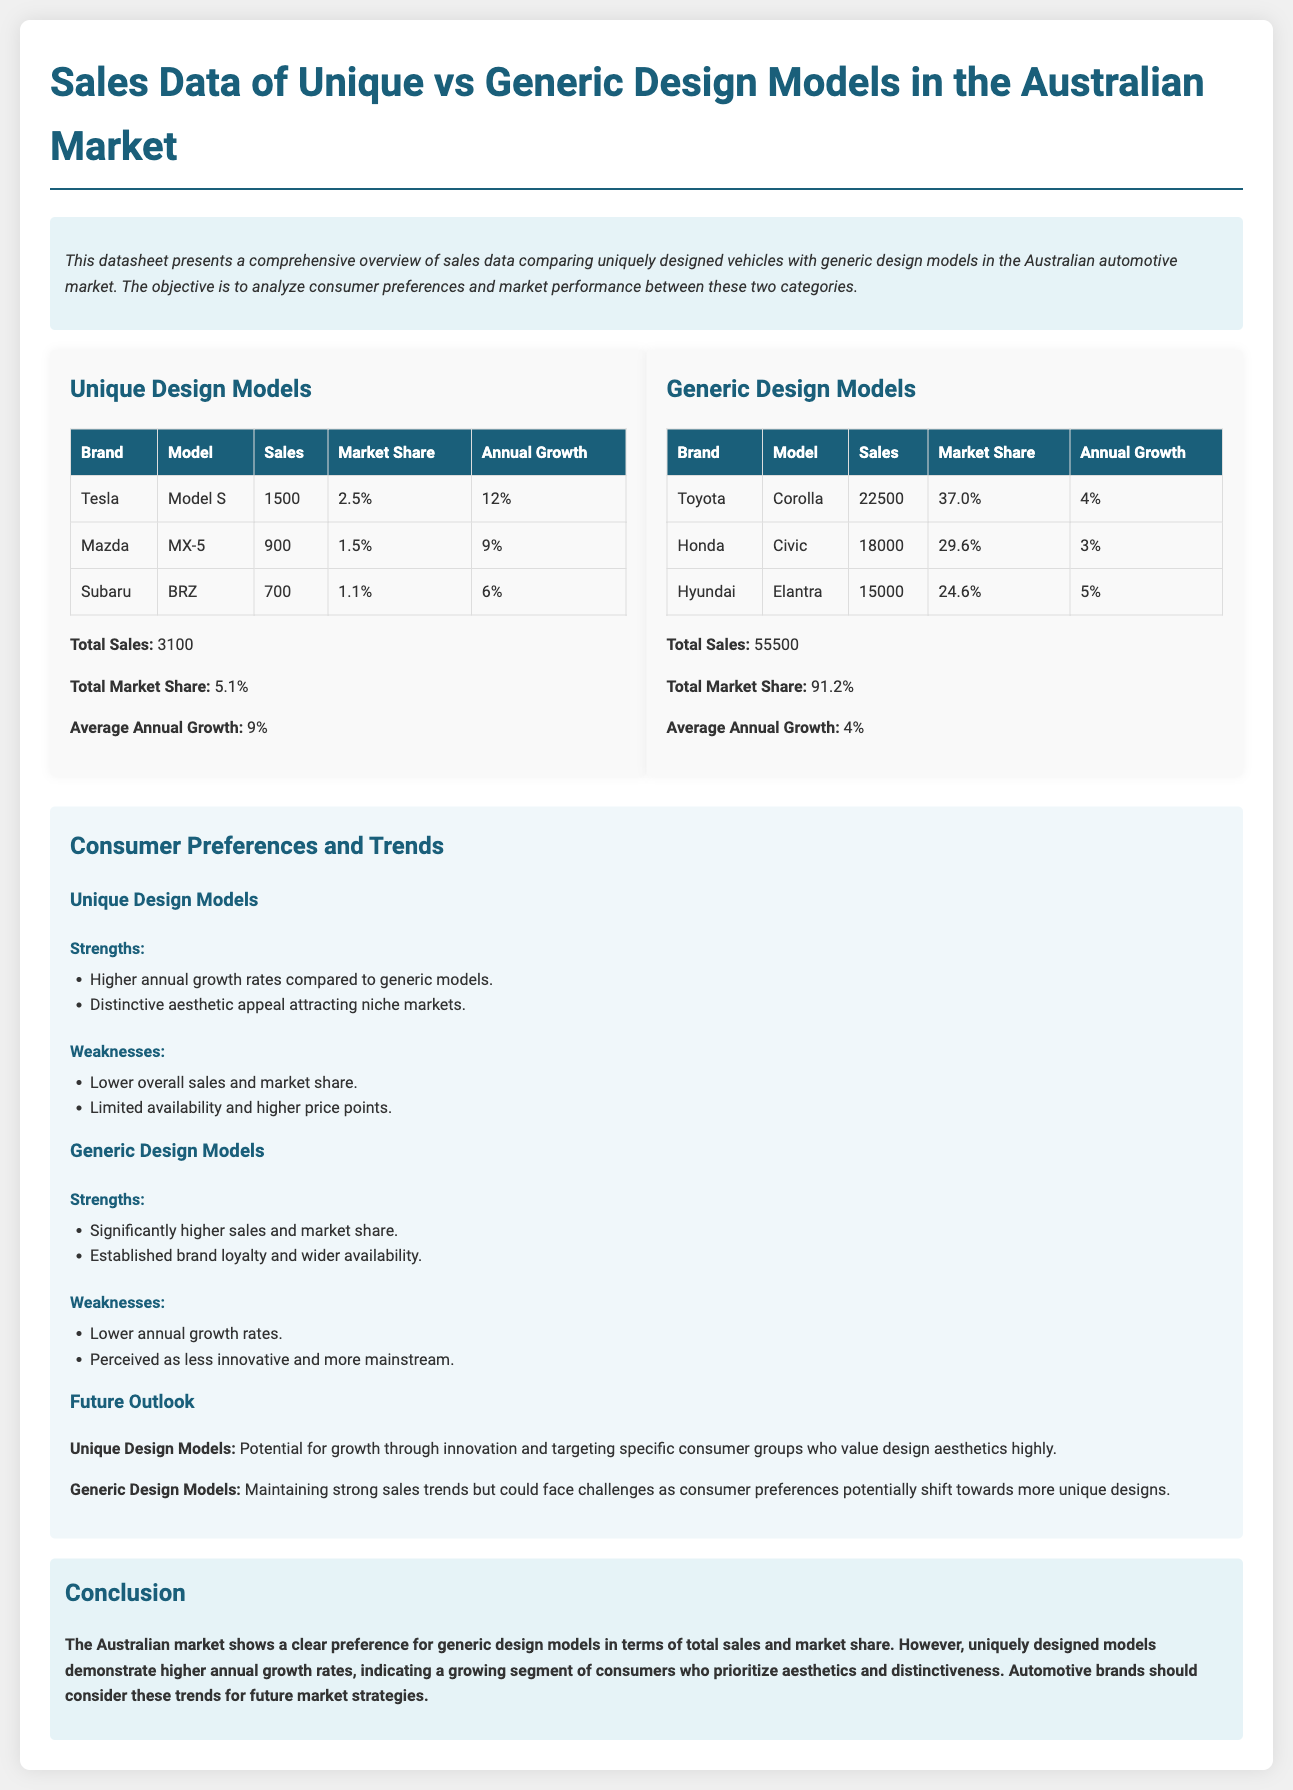What is the total sales of Unique Design Models? The total sales of Unique Design Models are listed in the document and are calculated by summing individual sales figures.
Answer: 3100 What is the market share percentage of Generic Design Models? The document states the market share percentage of Generic Design Models calculated from the total sales relative to the total market.
Answer: 91.2% Which brand has the highest sales in Unique Design Models? The document lists the sales figures for each brand under Unique Design Models, identifying the brand with the highest sales.
Answer: Tesla What is the average annual growth for Unique Design Models? The document provides the average annual growth figure specifically for Unique Design Models in the summary.
Answer: 9% What is the weakness of Generic Design Models mentioned in the analysis? The analysis section lists weaknesses associated with Generic Design Models, allowing for identification of the stated weaknesses.
Answer: Lower annual growth rates What was the annual growth percentage for Toyota Corolla? The document specifies the annual growth percentage for each model under Generic Design Models, particularly highlighting Toyota Corolla’s growth rate.
Answer: 4% What is the total market share of Unique Design Models? The total market share for Unique Design Models is explicitly mentioned as part of the sales data summary in the document.
Answer: 5.1% What does the conclusion suggest about the future of Unique Design Models? The conclusion discusses market trends and indicates the unique models' potential for growth, reflecting on consumer preferences.
Answer: Potential for growth through innovation What are the strengths of Subaru BRZ as listed in the Unique Design Models section? The document outlines the strengths for each Unique Design Model, including specific attributes for the Subaru BRZ.
Answer: Higher annual growth rates What is the total sales figure for Generic Design Models? The total sales figure for Generic Design Models is combined from individual sales and presented in the overall summary.
Answer: 55500 